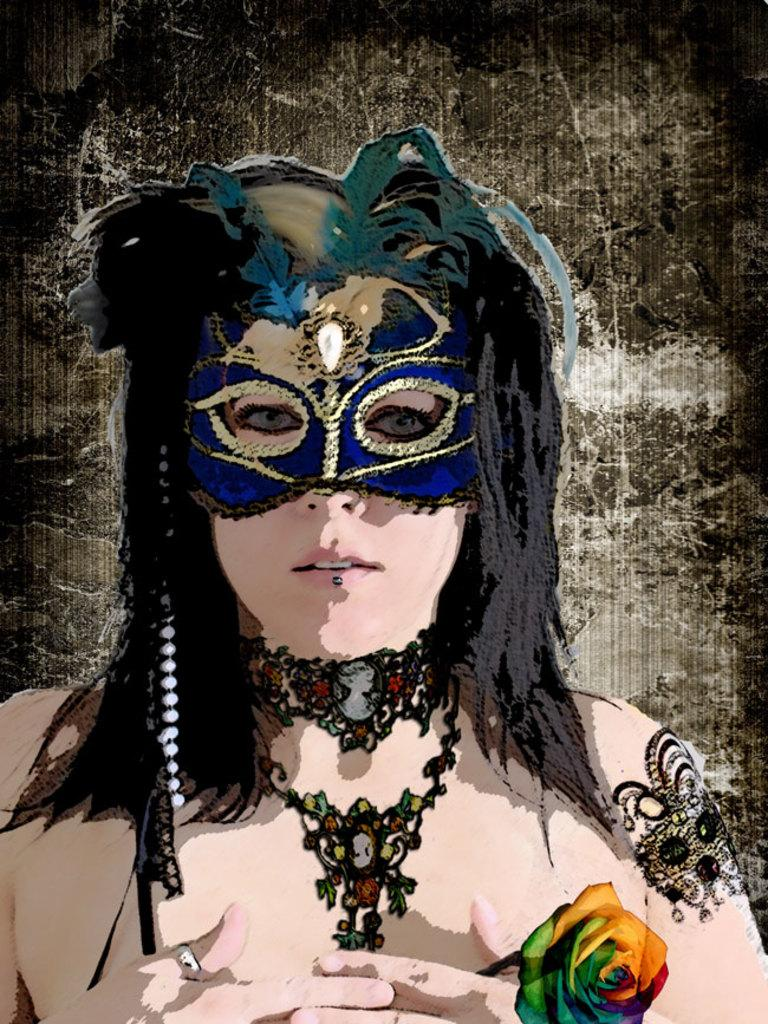What is the main subject of the painting in the image? The main subject of the painting in the image is a woman. What is the woman wearing on her face? The woman is wearing a blue mask. What type of jewelry is the woman wearing? The woman is wearing a necklace. What object is the woman holding in the painting? The woman is holding a flower. What type of fiction is the woman reading on stage in the image? There is no indication in the image that the woman is reading fiction or on a stage; it is a painting of a woman wearing a blue mask, necklace, and holding a flower. 